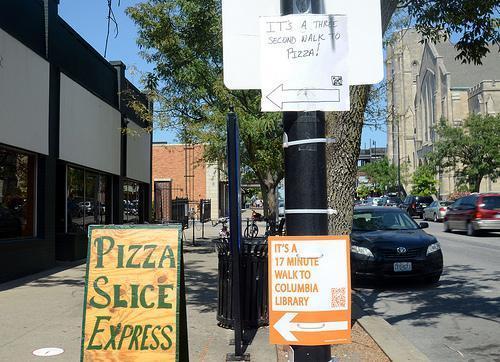How many people are pictured here?
Give a very brief answer. 0. 